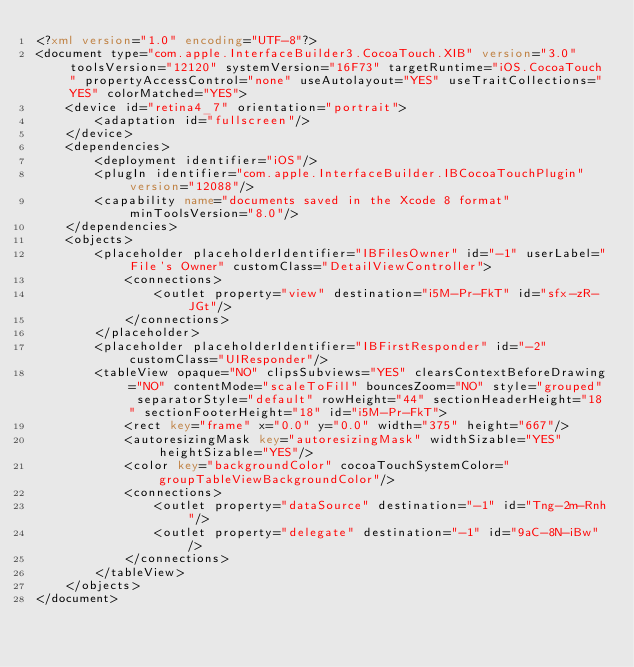Convert code to text. <code><loc_0><loc_0><loc_500><loc_500><_XML_><?xml version="1.0" encoding="UTF-8"?>
<document type="com.apple.InterfaceBuilder3.CocoaTouch.XIB" version="3.0" toolsVersion="12120" systemVersion="16F73" targetRuntime="iOS.CocoaTouch" propertyAccessControl="none" useAutolayout="YES" useTraitCollections="YES" colorMatched="YES">
    <device id="retina4_7" orientation="portrait">
        <adaptation id="fullscreen"/>
    </device>
    <dependencies>
        <deployment identifier="iOS"/>
        <plugIn identifier="com.apple.InterfaceBuilder.IBCocoaTouchPlugin" version="12088"/>
        <capability name="documents saved in the Xcode 8 format" minToolsVersion="8.0"/>
    </dependencies>
    <objects>
        <placeholder placeholderIdentifier="IBFilesOwner" id="-1" userLabel="File's Owner" customClass="DetailViewController">
            <connections>
                <outlet property="view" destination="i5M-Pr-FkT" id="sfx-zR-JGt"/>
            </connections>
        </placeholder>
        <placeholder placeholderIdentifier="IBFirstResponder" id="-2" customClass="UIResponder"/>
        <tableView opaque="NO" clipsSubviews="YES" clearsContextBeforeDrawing="NO" contentMode="scaleToFill" bouncesZoom="NO" style="grouped" separatorStyle="default" rowHeight="44" sectionHeaderHeight="18" sectionFooterHeight="18" id="i5M-Pr-FkT">
            <rect key="frame" x="0.0" y="0.0" width="375" height="667"/>
            <autoresizingMask key="autoresizingMask" widthSizable="YES" heightSizable="YES"/>
            <color key="backgroundColor" cocoaTouchSystemColor="groupTableViewBackgroundColor"/>
            <connections>
                <outlet property="dataSource" destination="-1" id="Tng-2m-Rnh"/>
                <outlet property="delegate" destination="-1" id="9aC-8N-iBw"/>
            </connections>
        </tableView>
    </objects>
</document>
</code> 